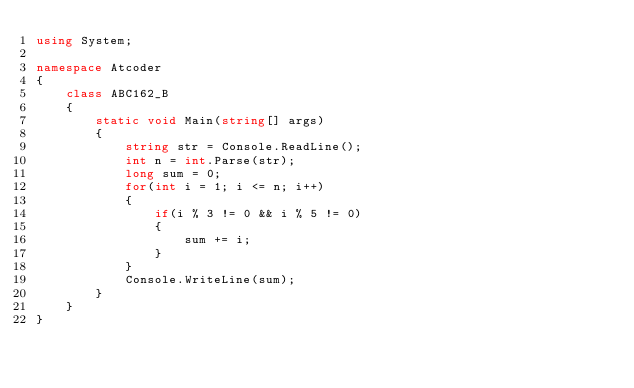<code> <loc_0><loc_0><loc_500><loc_500><_C#_>using System;

namespace Atcoder
{
    class ABC162_B
    {
        static void Main(string[] args)
        {
            string str = Console.ReadLine();
            int n = int.Parse(str);
            long sum = 0;
            for(int i = 1; i <= n; i++)
            {
                if(i % 3 != 0 && i % 5 != 0)
                {
                    sum += i;
                }
            }
            Console.WriteLine(sum);
        }
    }
}
</code> 